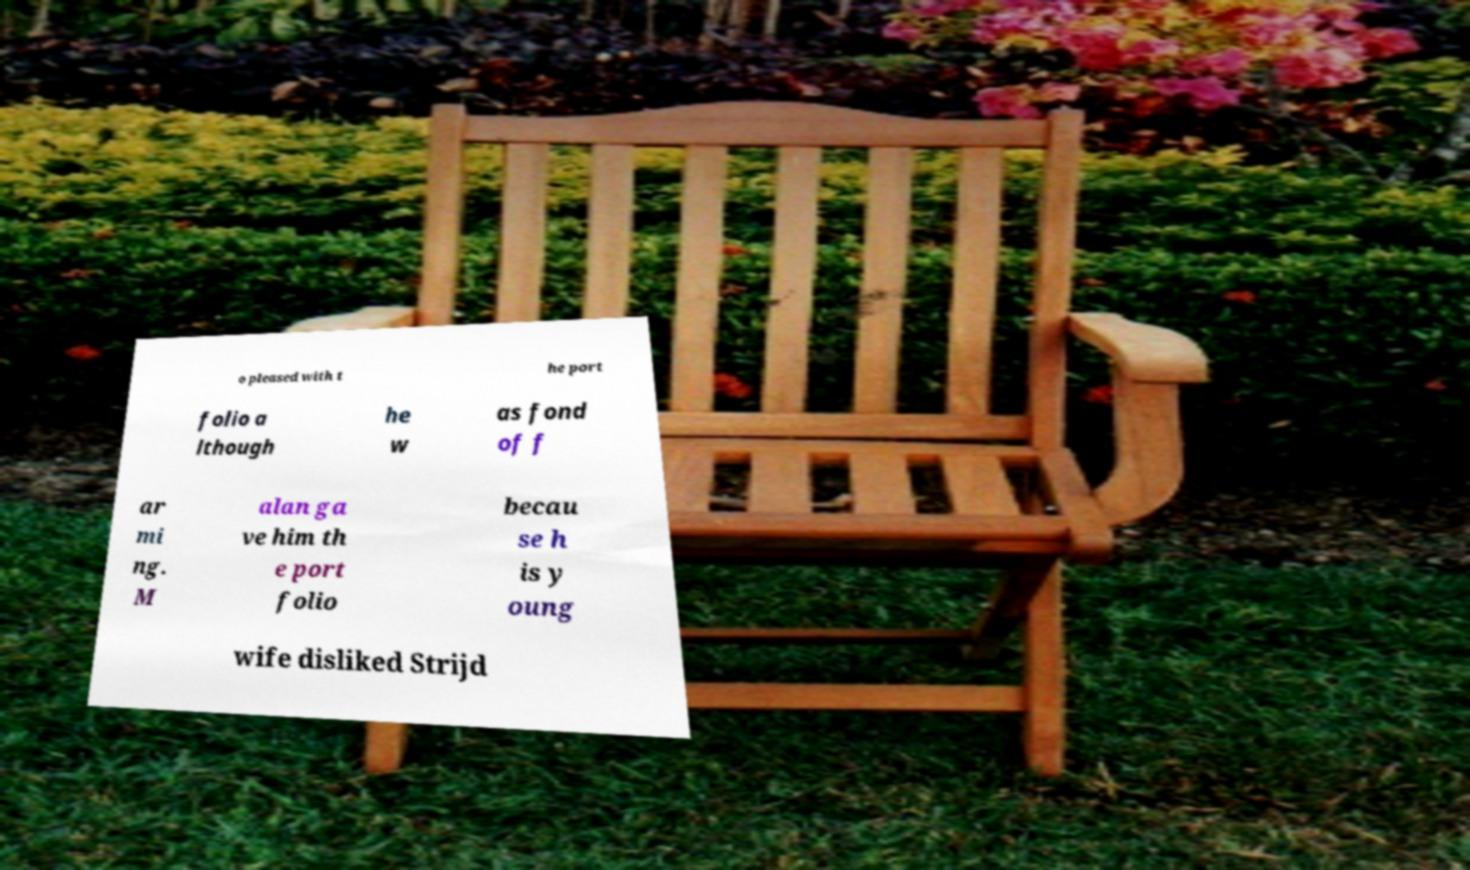Could you extract and type out the text from this image? o pleased with t he port folio a lthough he w as fond of f ar mi ng. M alan ga ve him th e port folio becau se h is y oung wife disliked Strijd 